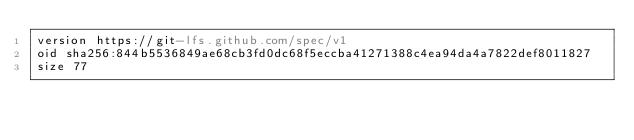Convert code to text. <code><loc_0><loc_0><loc_500><loc_500><_YAML_>version https://git-lfs.github.com/spec/v1
oid sha256:844b5536849ae68cb3fd0dc68f5eccba41271388c4ea94da4a7822def8011827
size 77
</code> 